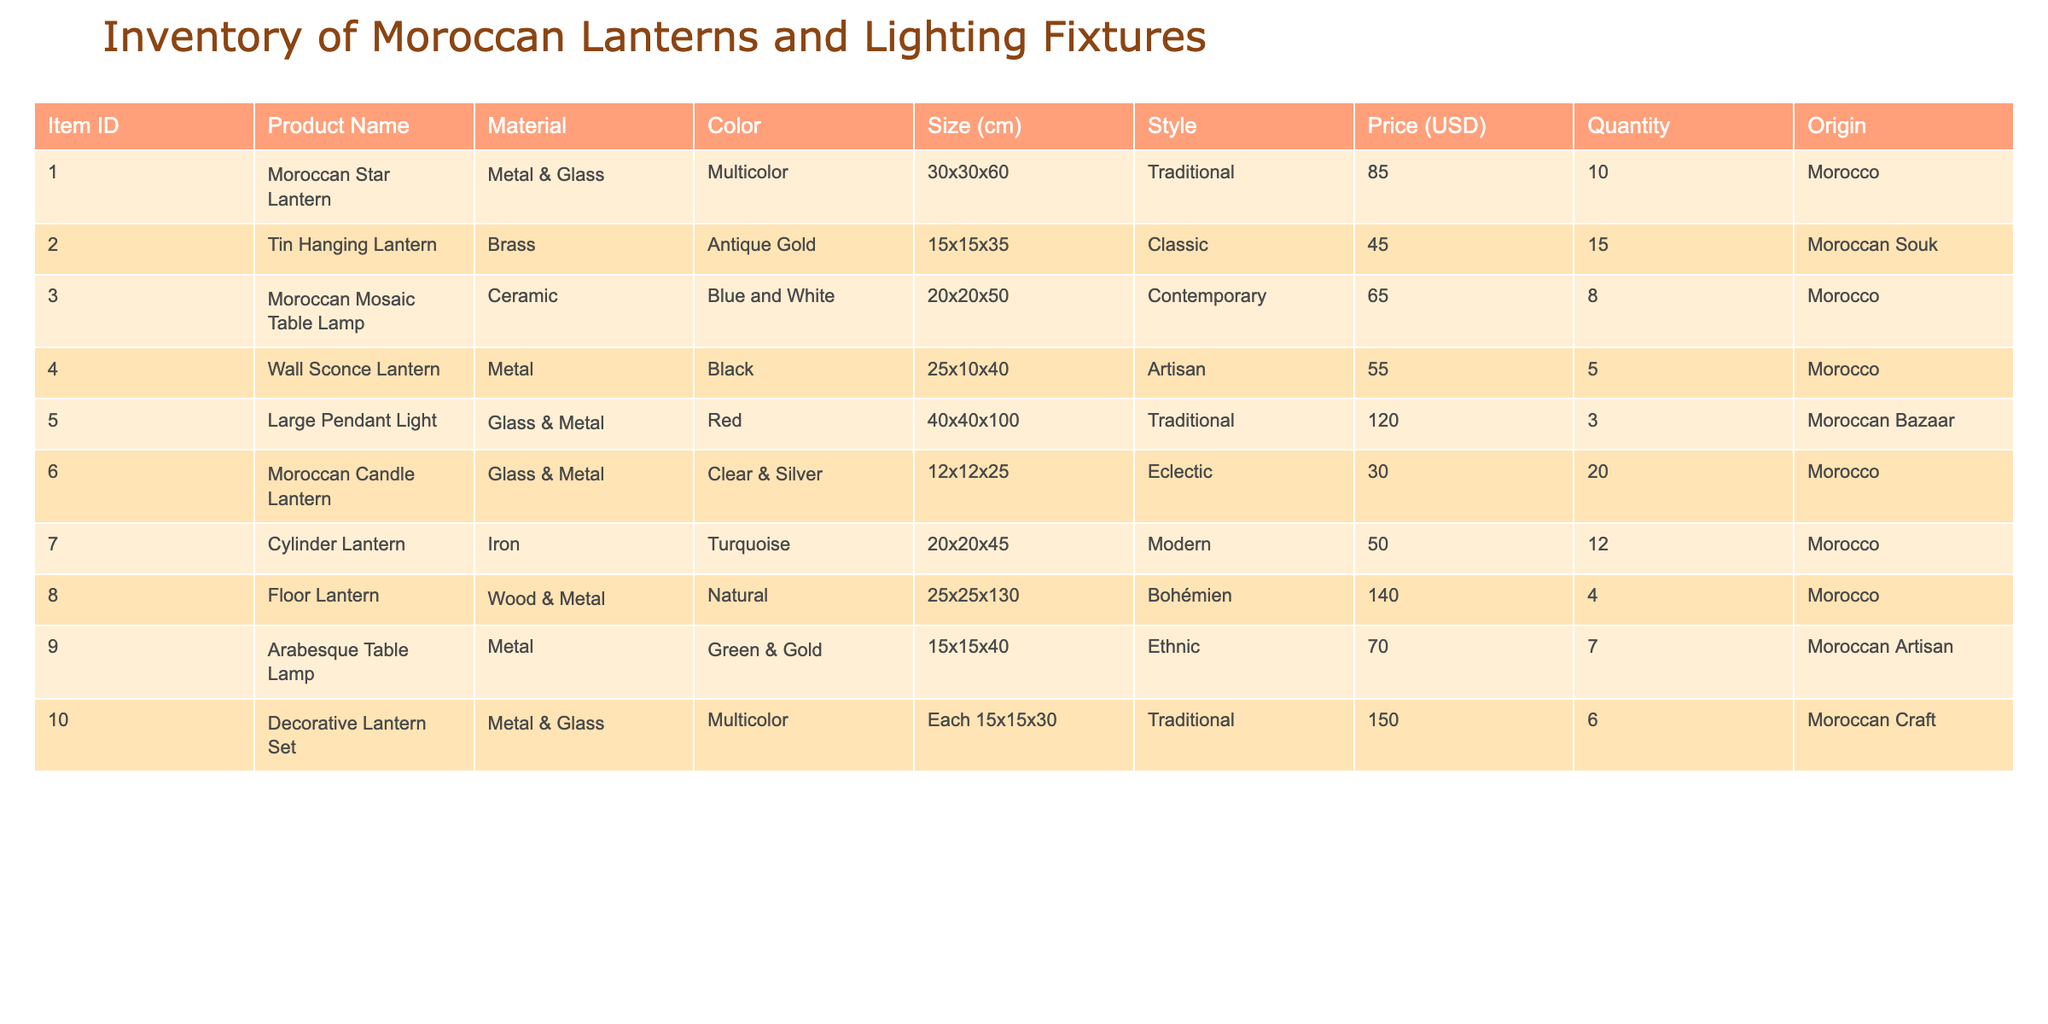What is the price of the Moroccan Star Lantern? The price of the Moroccan Star Lantern can be found directly in the table under the Price column next to its Product Name. It states that the Price is 85.00 USD.
Answer: 85.00 USD How many total Tin Hanging Lanterns are available? The total quantity of Tin Hanging Lanterns is listed in the Quantity column beside its product name. It shows that there are 15 units available.
Answer: 15 What is the total price of all the Decorative Lantern Sets in inventory? To find the total price, multiply the price per unit (150.00 USD) by the quantity available (6). The calculation is 150.00 * 6 = 900.00 USD.
Answer: 900.00 USD Is there a Moroccan Candle Lantern available in a different color apart from Clear & Silver? According to the table, the Moroccan Candle Lantern is only listed in one color, which is Clear & Silver. Therefore, the statement is false.
Answer: No Which item has the highest price in the inventory? By examining the Price column, we can see that the Large Pendant Light has the highest price at 120.00 USD.
Answer: Large Pendant Light What is the average size of Moroccan lighting fixtures in the inventory? To calculate the average size, convert the sizes from the Size column into a numerical format (calculate the combined height, for example). The heights are 60, 35, 50, 40, 100, 25, 45, 130, 40, and 30 cm. Adding these up gives 510 cm. There are 10 items, so the average is 510/10 = 51 cm.
Answer: 51 cm How many different styles of lanterns are represented in the inventory? From the Style column, the different styles listed are Traditional, Classic, Contemporary, Artisan, Eclectic, Modern, Bohémien, Ethnic. Counting these gives a total of 8 distinct styles.
Answer: 8 Are there any items made of ceramic in the inventory? Checking the Material column, we see that the Moroccan Mosaic Table Lamp is the only item made of ceramic. Thus, the answer is yes.
Answer: Yes How many items in the inventory are colored in multicolor? By reviewing the Color column, we find that both the Moroccan Star Lantern and the Decorative Lantern Set are multicolored. Therefore, there are 2 items in multicolor.
Answer: 2 